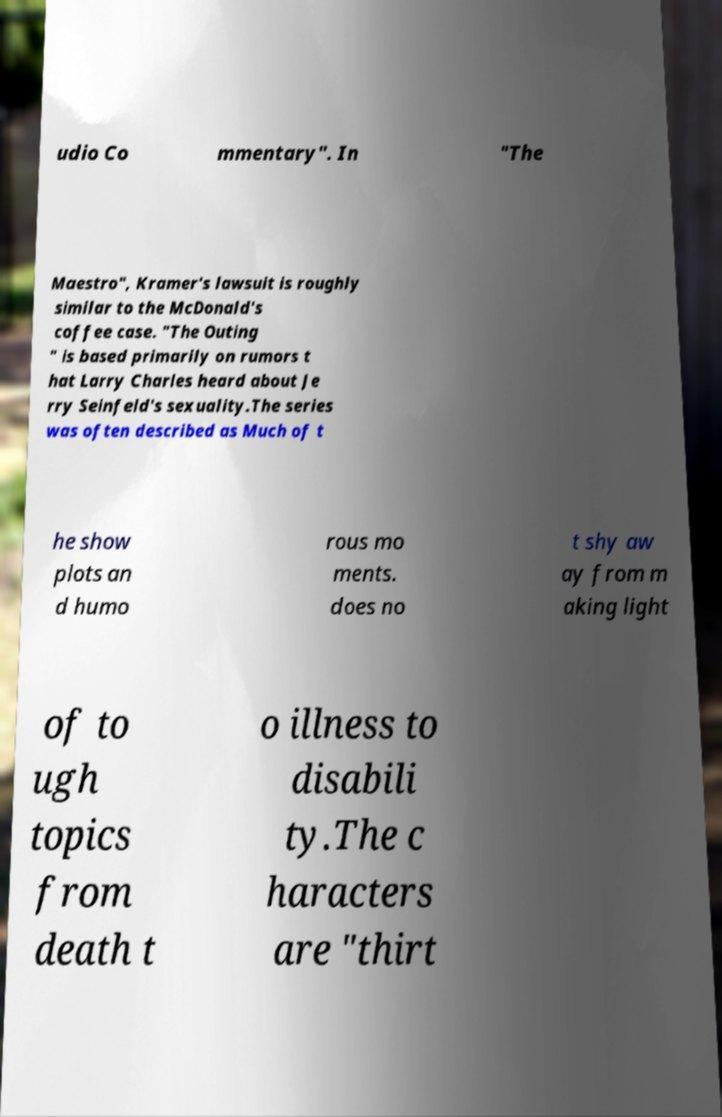There's text embedded in this image that I need extracted. Can you transcribe it verbatim? udio Co mmentary". In "The Maestro", Kramer's lawsuit is roughly similar to the McDonald's coffee case. "The Outing " is based primarily on rumors t hat Larry Charles heard about Je rry Seinfeld's sexuality.The series was often described as Much of t he show plots an d humo rous mo ments. does no t shy aw ay from m aking light of to ugh topics from death t o illness to disabili ty.The c haracters are "thirt 